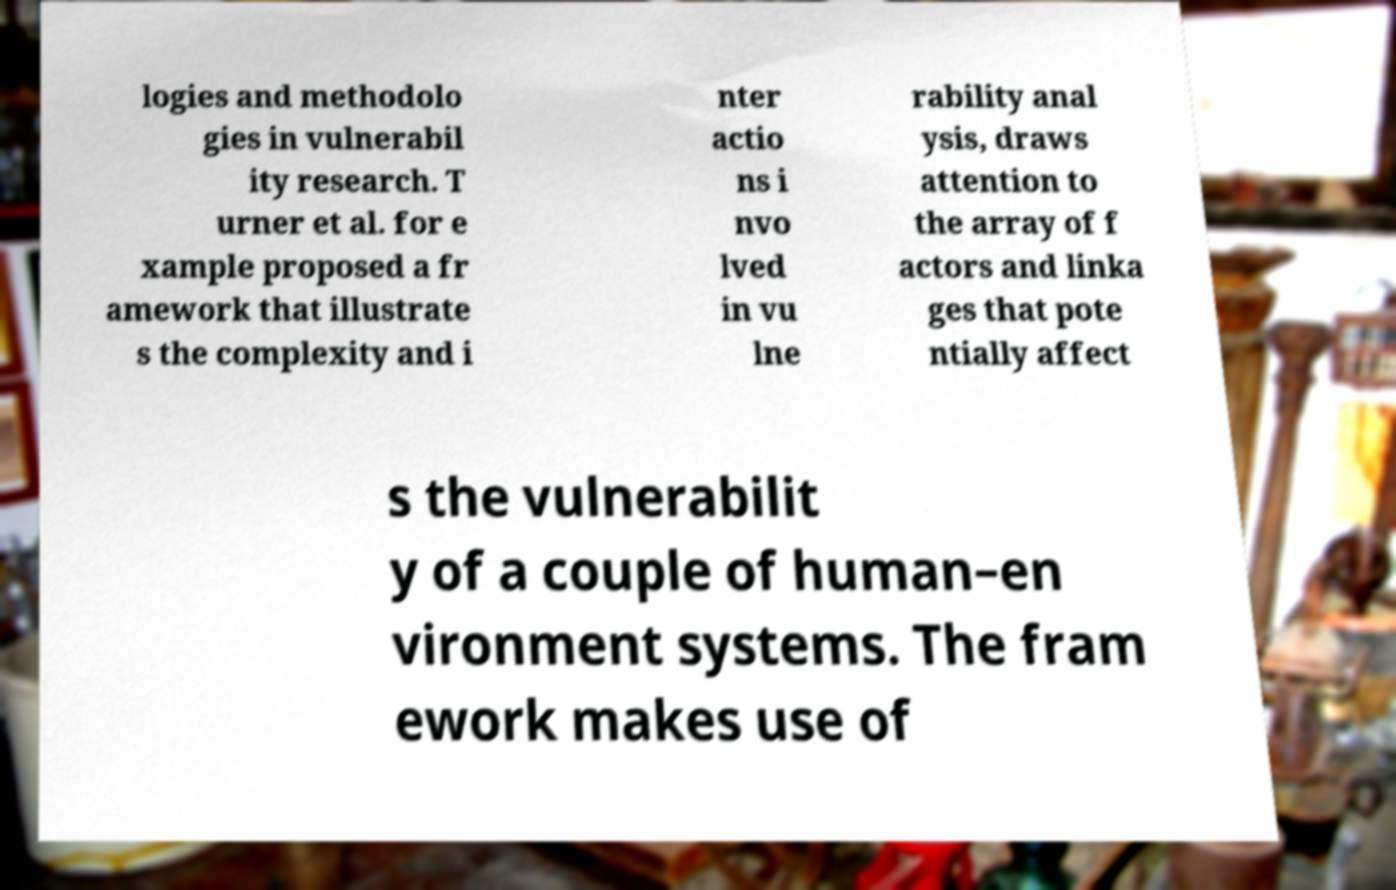Could you extract and type out the text from this image? logies and methodolo gies in vulnerabil ity research. T urner et al. for e xample proposed a fr amework that illustrate s the complexity and i nter actio ns i nvo lved in vu lne rability anal ysis, draws attention to the array of f actors and linka ges that pote ntially affect s the vulnerabilit y of a couple of human–en vironment systems. The fram ework makes use of 